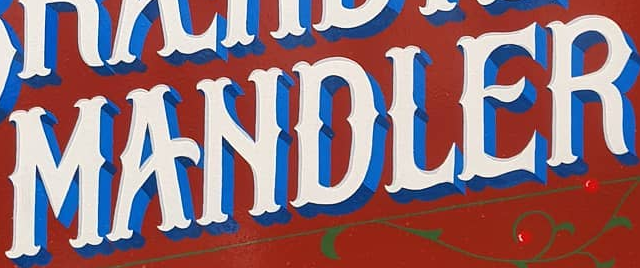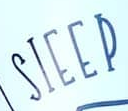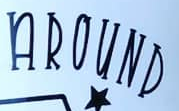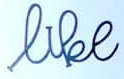What words can you see in these images in sequence, separated by a semicolon? MANDLER; SIEEP; AROUND; like 